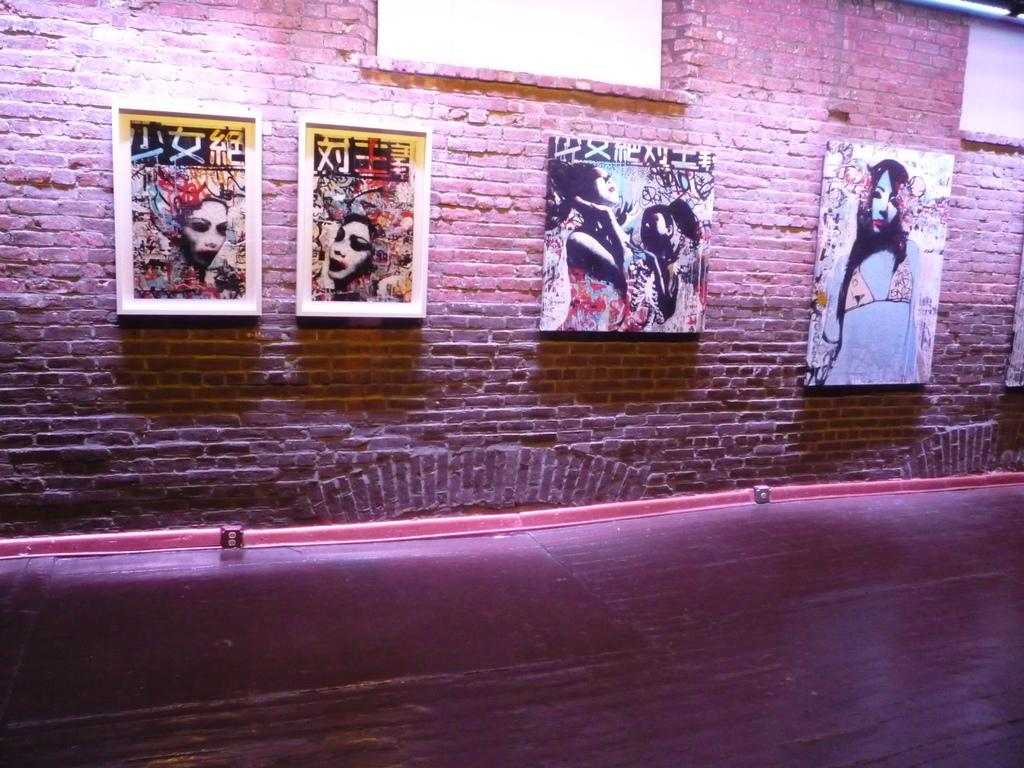What is present on the wall in the image? The wall has photo frames on it. How many photo frames can be seen on the wall? The number of photo frames cannot be determined from the provided facts. What type of destruction can be seen happening to the crib in the image? There is no crib present in the image, and therefore no destruction can be observed. 